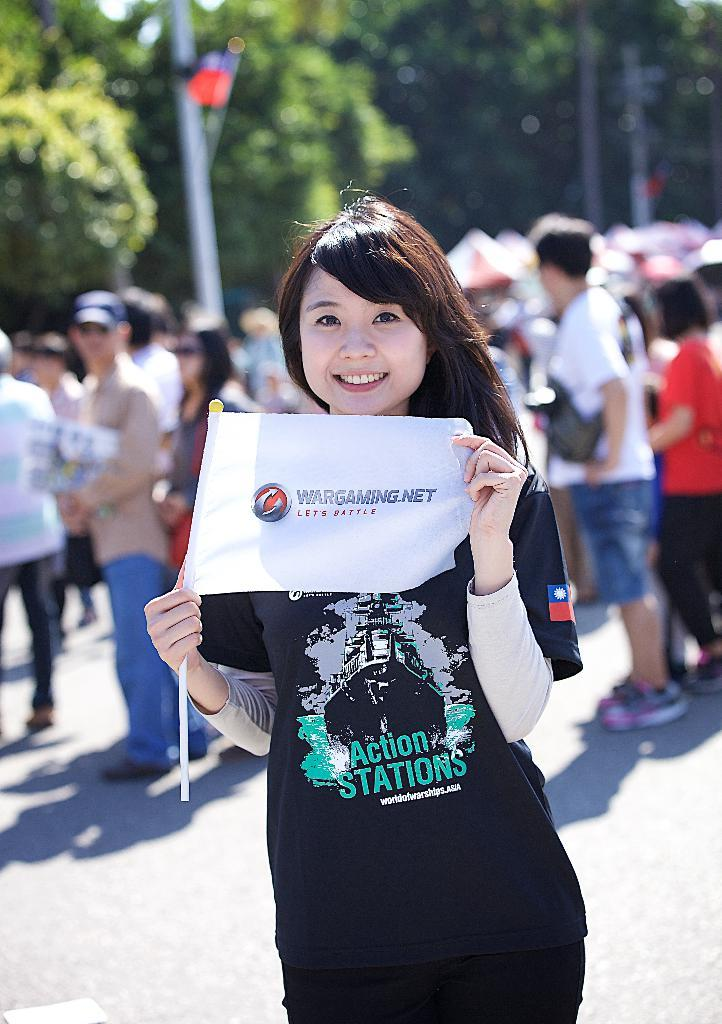What is the woman in the image holding? The woman is holding a poster with a stick in the image. What can be seen in the background of the image? There are trees and people visible in the background of the image. How would you describe the quality of the background in the image? The background of the image is blurry. What type of error can be seen on the poster in the image? There is no error visible on the poster in the image. What kind of chalk is being used to write on the quartz in the image? There is no chalk or quartz present in the image. 